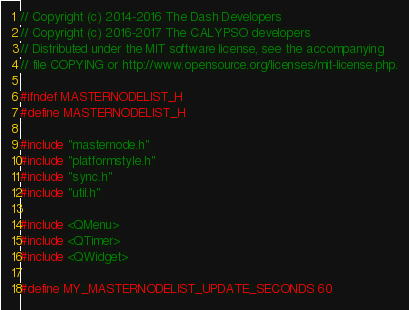<code> <loc_0><loc_0><loc_500><loc_500><_C_>// Copyright (c) 2014-2016 The Dash Developers
// Copyright (c) 2016-2017 The CALYPSO developers
// Distributed under the MIT software license, see the accompanying
// file COPYING or http://www.opensource.org/licenses/mit-license.php.

#ifndef MASTERNODELIST_H
#define MASTERNODELIST_H

#include "masternode.h"
#include "platformstyle.h"
#include "sync.h"
#include "util.h"

#include <QMenu>
#include <QTimer>
#include <QWidget>

#define MY_MASTERNODELIST_UPDATE_SECONDS 60</code> 